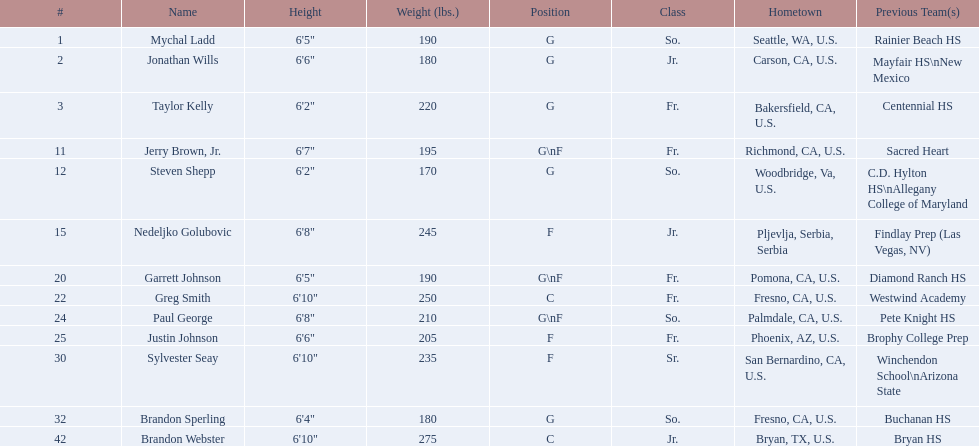For the 2009-10 fresno state bulldogs, in which class was each team participant? So., Jr., Fr., Fr., So., Jr., Fr., Fr., So., Fr., Sr., So., Jr. Which of them was from a country other than the us? Jr. Who was this player? Nedeljko Golubovic. Who comprises the 2009-10 fresno state bulldogs men's basketball team? Mychal Ladd, Jonathan Wills, Taylor Kelly, Jerry Brown, Jr., Steven Shepp, Nedeljko Golubovic, Garrett Johnson, Greg Smith, Paul George, Justin Johnson, Sylvester Seay, Brandon Sperling, Brandon Webster. From this group, who are the forward players? Jerry Brown, Jr., Nedeljko Golubovic, Garrett Johnson, Paul George, Justin Johnson, Sylvester Seay. Which individuals solely play the forward position and no others? Nedeljko Golubovic, Justin Johnson, Sylvester Seay. Among them, who is the least tall? Justin Johnson. 